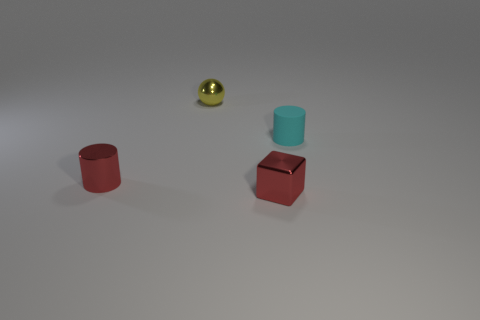Add 4 small brown balls. How many objects exist? 8 Subtract all cubes. How many objects are left? 3 Subtract 0 green cylinders. How many objects are left? 4 Subtract all red shiny cylinders. Subtract all tiny yellow shiny things. How many objects are left? 2 Add 4 small red cubes. How many small red cubes are left? 5 Add 3 small metallic cylinders. How many small metallic cylinders exist? 4 